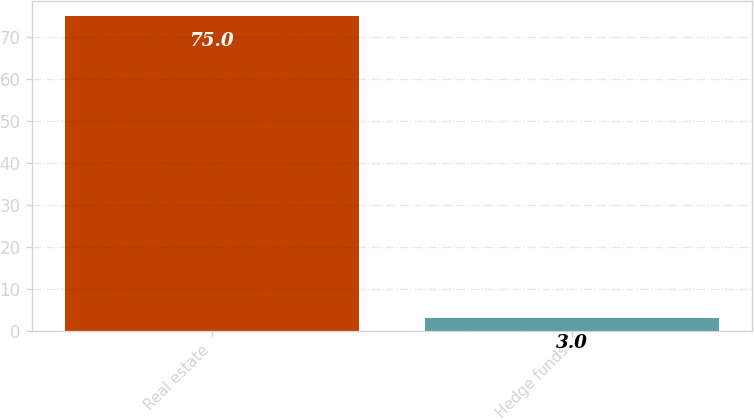Convert chart. <chart><loc_0><loc_0><loc_500><loc_500><bar_chart><fcel>Real estate<fcel>Hedge funds<nl><fcel>75<fcel>3<nl></chart> 